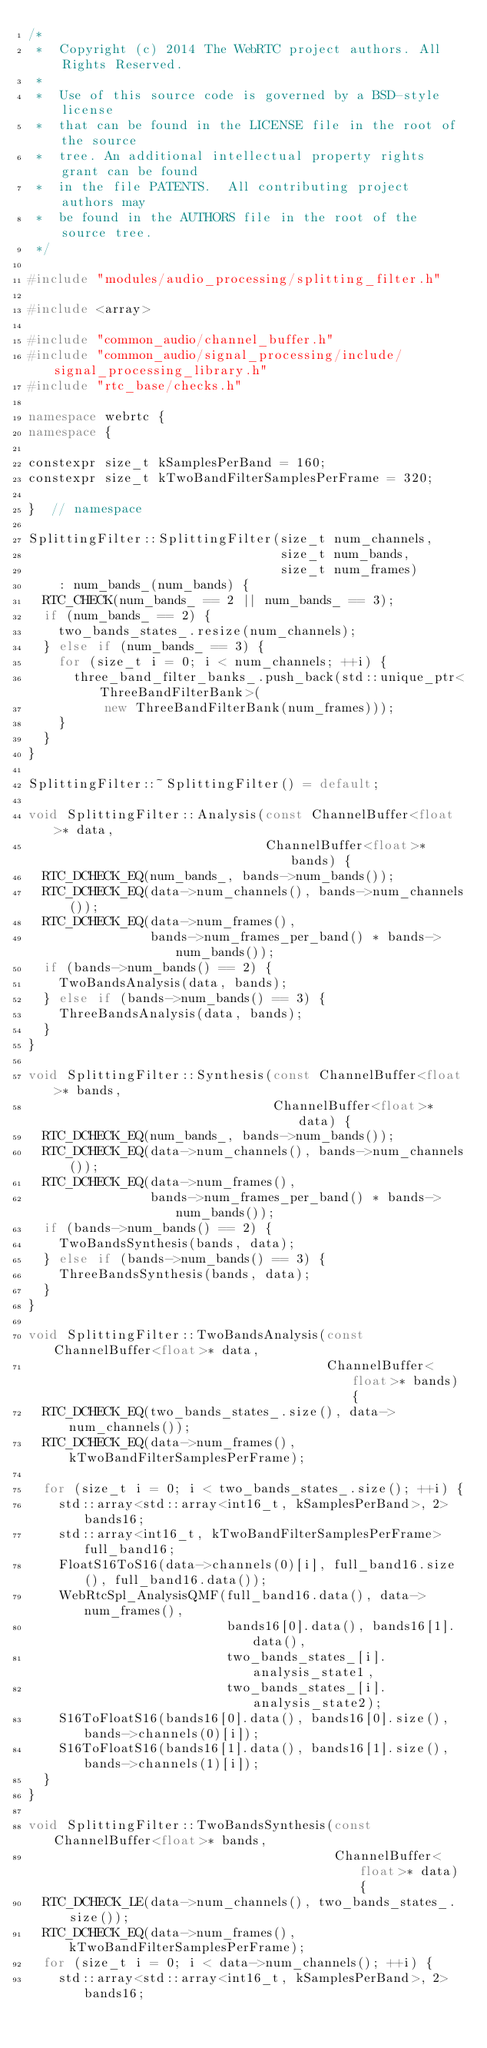<code> <loc_0><loc_0><loc_500><loc_500><_C++_>/*
 *  Copyright (c) 2014 The WebRTC project authors. All Rights Reserved.
 *
 *  Use of this source code is governed by a BSD-style license
 *  that can be found in the LICENSE file in the root of the source
 *  tree. An additional intellectual property rights grant can be found
 *  in the file PATENTS.  All contributing project authors may
 *  be found in the AUTHORS file in the root of the source tree.
 */

#include "modules/audio_processing/splitting_filter.h"

#include <array>

#include "common_audio/channel_buffer.h"
#include "common_audio/signal_processing/include/signal_processing_library.h"
#include "rtc_base/checks.h"

namespace webrtc {
namespace {

constexpr size_t kSamplesPerBand = 160;
constexpr size_t kTwoBandFilterSamplesPerFrame = 320;

}  // namespace

SplittingFilter::SplittingFilter(size_t num_channels,
                                 size_t num_bands,
                                 size_t num_frames)
    : num_bands_(num_bands) {
  RTC_CHECK(num_bands_ == 2 || num_bands_ == 3);
  if (num_bands_ == 2) {
    two_bands_states_.resize(num_channels);
  } else if (num_bands_ == 3) {
    for (size_t i = 0; i < num_channels; ++i) {
      three_band_filter_banks_.push_back(std::unique_ptr<ThreeBandFilterBank>(
          new ThreeBandFilterBank(num_frames)));
    }
  }
}

SplittingFilter::~SplittingFilter() = default;

void SplittingFilter::Analysis(const ChannelBuffer<float>* data,
                               ChannelBuffer<float>* bands) {
  RTC_DCHECK_EQ(num_bands_, bands->num_bands());
  RTC_DCHECK_EQ(data->num_channels(), bands->num_channels());
  RTC_DCHECK_EQ(data->num_frames(),
                bands->num_frames_per_band() * bands->num_bands());
  if (bands->num_bands() == 2) {
    TwoBandsAnalysis(data, bands);
  } else if (bands->num_bands() == 3) {
    ThreeBandsAnalysis(data, bands);
  }
}

void SplittingFilter::Synthesis(const ChannelBuffer<float>* bands,
                                ChannelBuffer<float>* data) {
  RTC_DCHECK_EQ(num_bands_, bands->num_bands());
  RTC_DCHECK_EQ(data->num_channels(), bands->num_channels());
  RTC_DCHECK_EQ(data->num_frames(),
                bands->num_frames_per_band() * bands->num_bands());
  if (bands->num_bands() == 2) {
    TwoBandsSynthesis(bands, data);
  } else if (bands->num_bands() == 3) {
    ThreeBandsSynthesis(bands, data);
  }
}

void SplittingFilter::TwoBandsAnalysis(const ChannelBuffer<float>* data,
                                       ChannelBuffer<float>* bands) {
  RTC_DCHECK_EQ(two_bands_states_.size(), data->num_channels());
  RTC_DCHECK_EQ(data->num_frames(), kTwoBandFilterSamplesPerFrame);

  for (size_t i = 0; i < two_bands_states_.size(); ++i) {
    std::array<std::array<int16_t, kSamplesPerBand>, 2> bands16;
    std::array<int16_t, kTwoBandFilterSamplesPerFrame> full_band16;
    FloatS16ToS16(data->channels(0)[i], full_band16.size(), full_band16.data());
    WebRtcSpl_AnalysisQMF(full_band16.data(), data->num_frames(),
                          bands16[0].data(), bands16[1].data(),
                          two_bands_states_[i].analysis_state1,
                          two_bands_states_[i].analysis_state2);
    S16ToFloatS16(bands16[0].data(), bands16[0].size(), bands->channels(0)[i]);
    S16ToFloatS16(bands16[1].data(), bands16[1].size(), bands->channels(1)[i]);
  }
}

void SplittingFilter::TwoBandsSynthesis(const ChannelBuffer<float>* bands,
                                        ChannelBuffer<float>* data) {
  RTC_DCHECK_LE(data->num_channels(), two_bands_states_.size());
  RTC_DCHECK_EQ(data->num_frames(), kTwoBandFilterSamplesPerFrame);
  for (size_t i = 0; i < data->num_channels(); ++i) {
    std::array<std::array<int16_t, kSamplesPerBand>, 2> bands16;</code> 